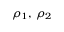<formula> <loc_0><loc_0><loc_500><loc_500>\rho _ { 1 } , \, \rho _ { 2 }</formula> 